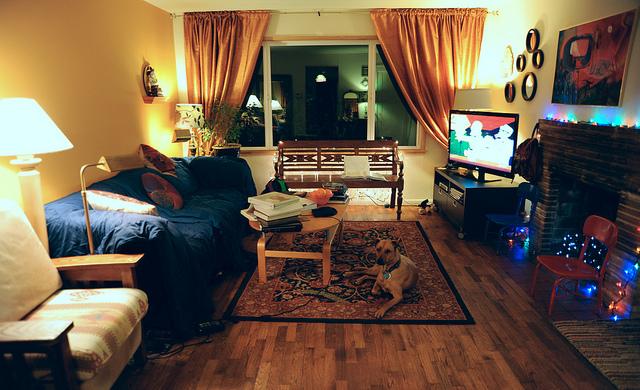Are there lights around the fireplace?
Keep it brief. Yes. Is that a bulldog on the floor?
Concise answer only. No. Is the television turned on or off?
Give a very brief answer. On. 